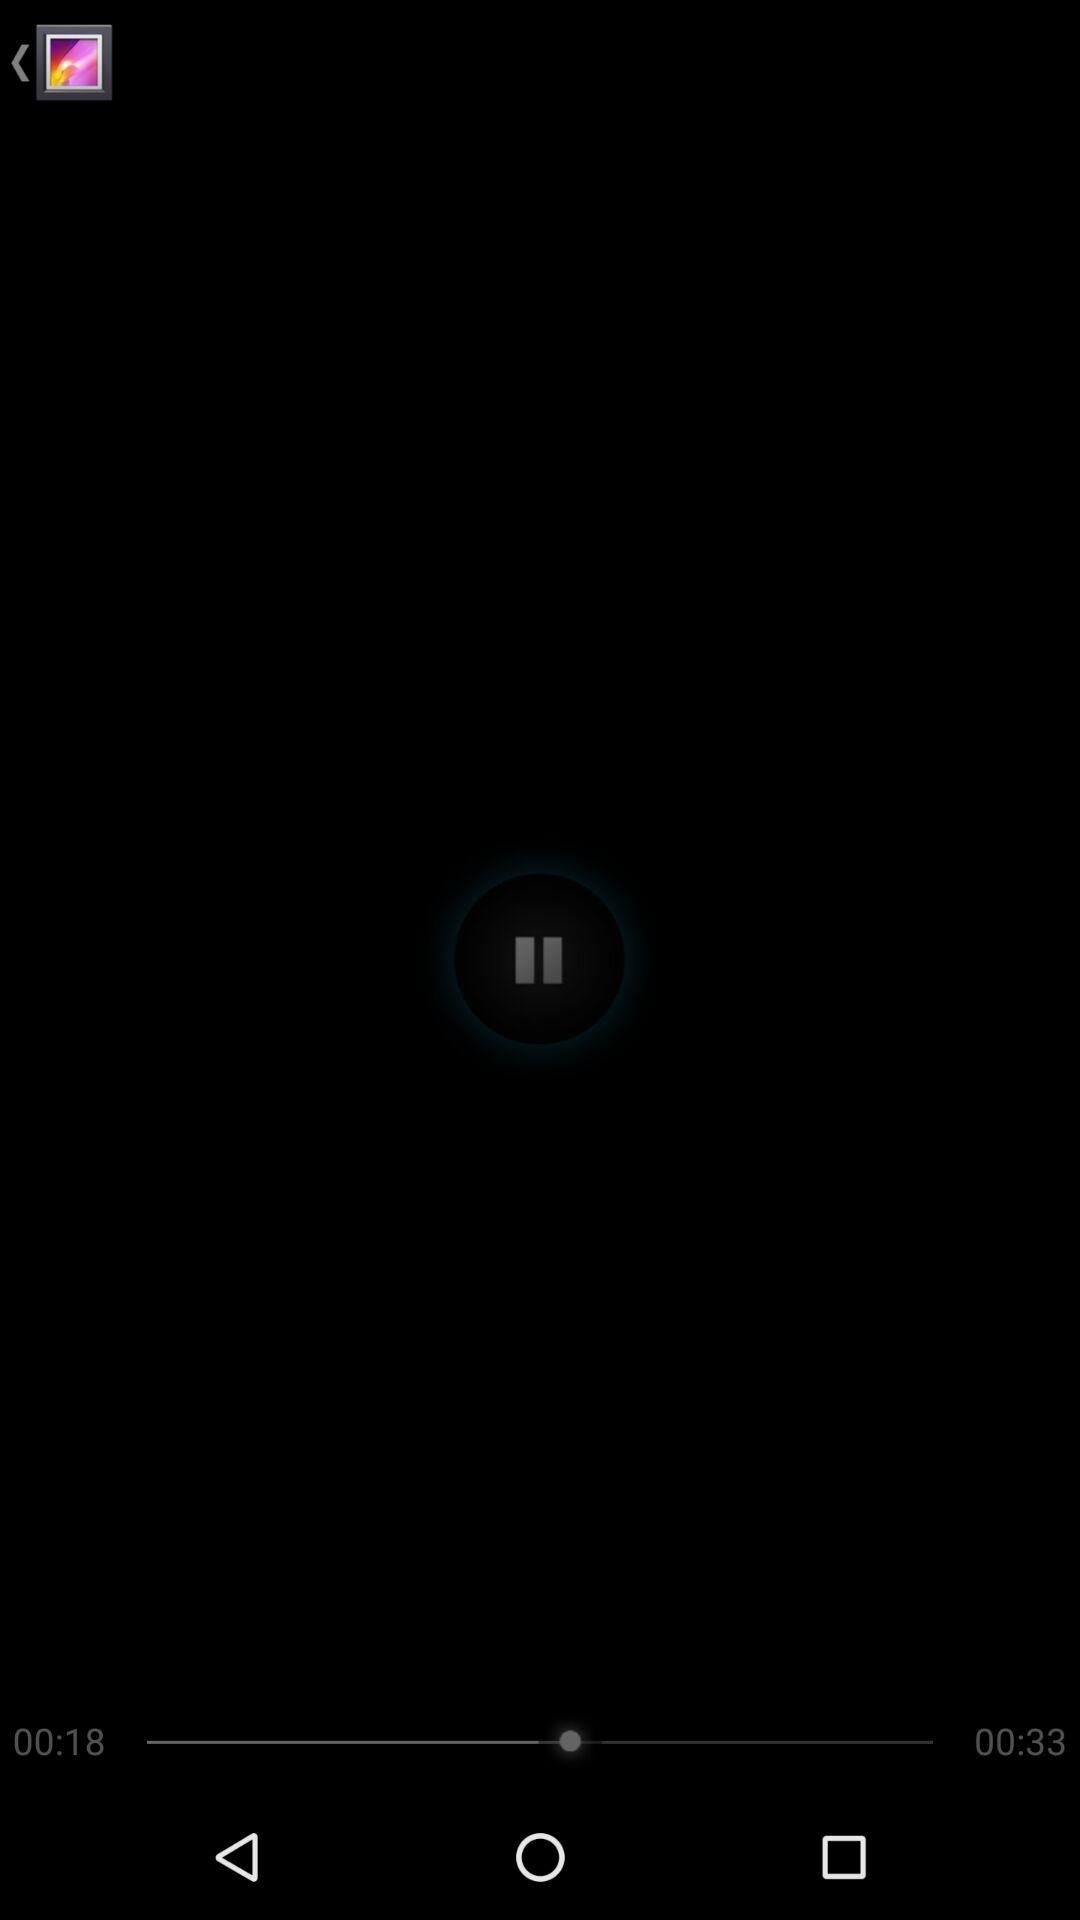How many seconds are there between 00:18 and 00:33?
Answer the question using a single word or phrase. 15 